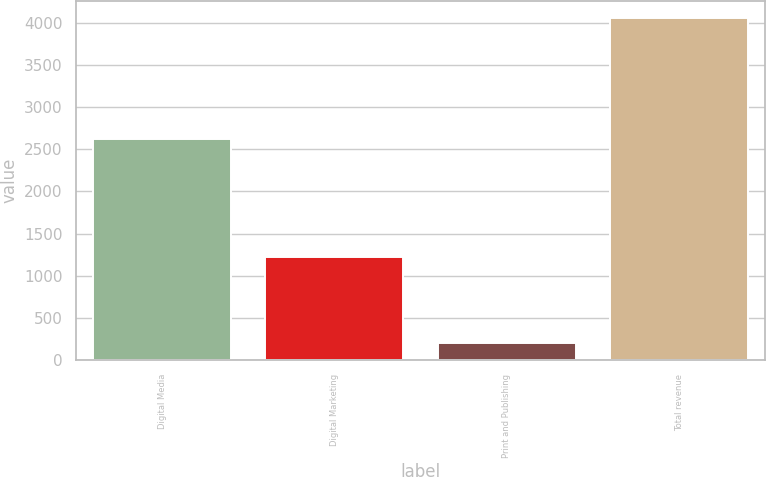<chart> <loc_0><loc_0><loc_500><loc_500><bar_chart><fcel>Digital Media<fcel>Digital Marketing<fcel>Print and Publishing<fcel>Total revenue<nl><fcel>2625.9<fcel>1228.8<fcel>200.5<fcel>4055.2<nl></chart> 